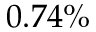<formula> <loc_0><loc_0><loc_500><loc_500>0 . 7 4 \%</formula> 